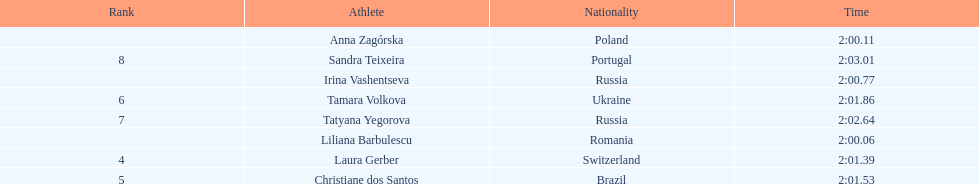What was the time difference between the first place finisher and the eighth place finisher? 2.95. Parse the table in full. {'header': ['Rank', 'Athlete', 'Nationality', 'Time'], 'rows': [['', 'Anna Zagórska', 'Poland', '2:00.11'], ['8', 'Sandra Teixeira', 'Portugal', '2:03.01'], ['', 'Irina Vashentseva', 'Russia', '2:00.77'], ['6', 'Tamara Volkova', 'Ukraine', '2:01.86'], ['7', 'Tatyana Yegorova', 'Russia', '2:02.64'], ['', 'Liliana Barbulescu', 'Romania', '2:00.06'], ['4', 'Laura Gerber', 'Switzerland', '2:01.39'], ['5', 'Christiane dos Santos', 'Brazil', '2:01.53']]} 